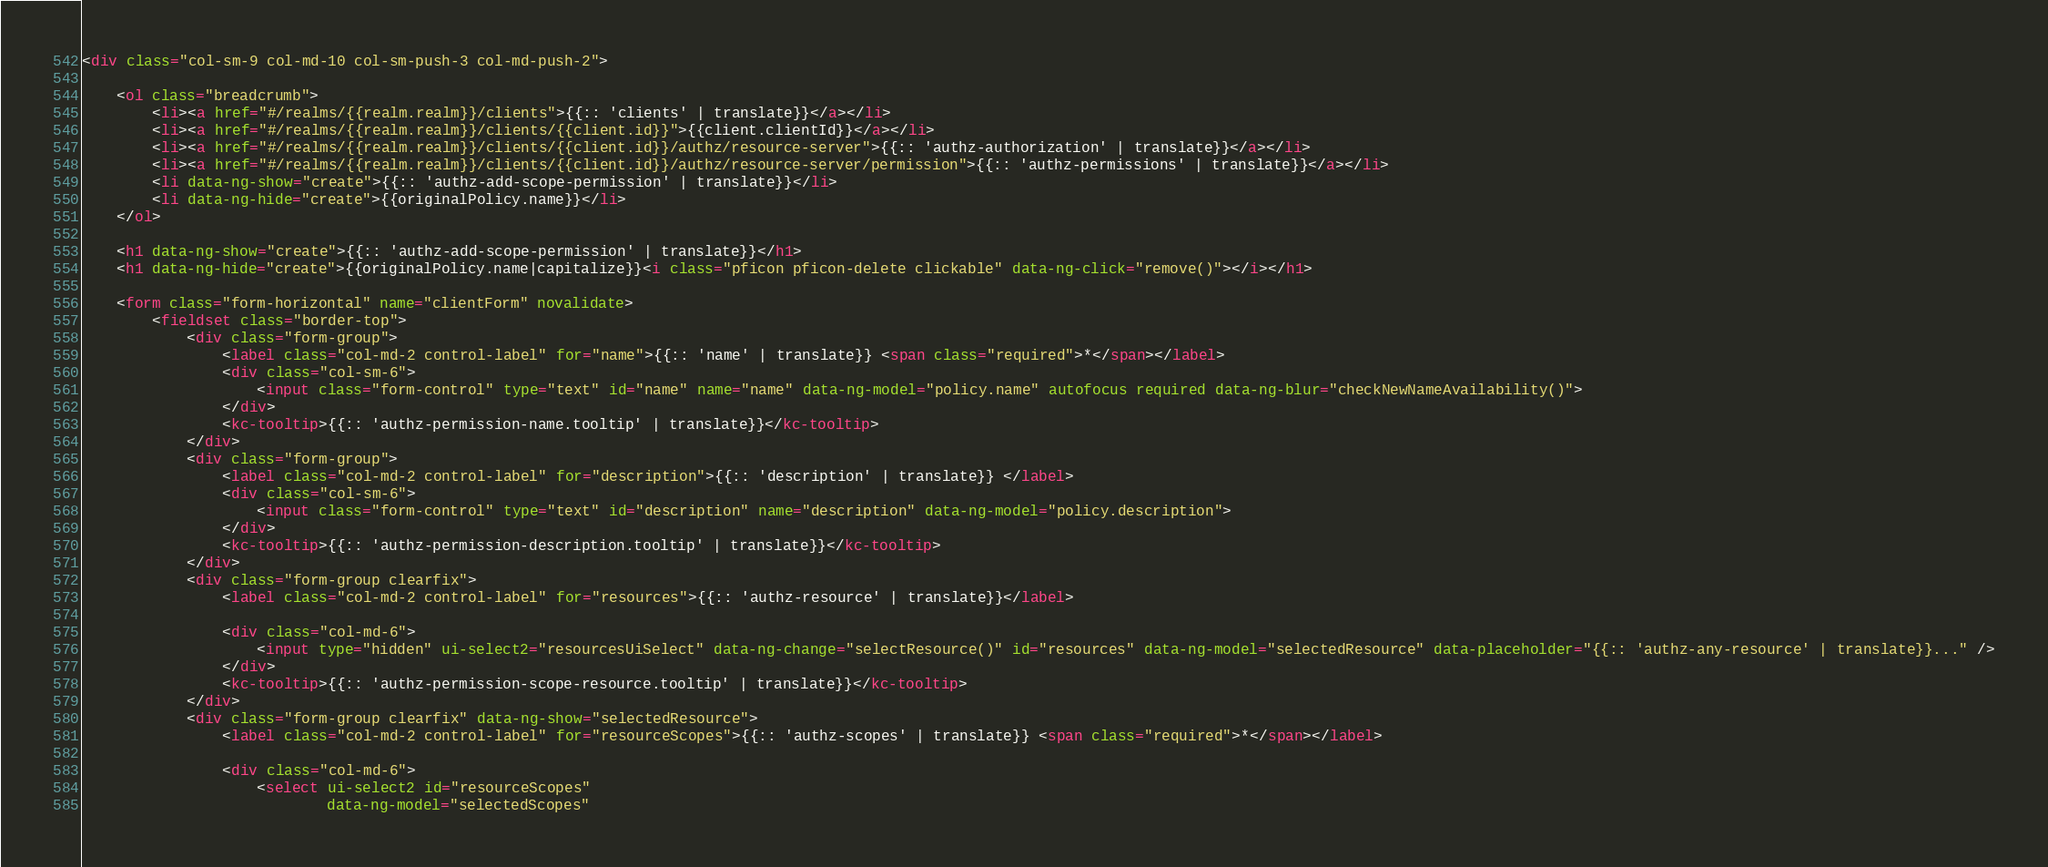<code> <loc_0><loc_0><loc_500><loc_500><_HTML_><div class="col-sm-9 col-md-10 col-sm-push-3 col-md-push-2">

    <ol class="breadcrumb">
        <li><a href="#/realms/{{realm.realm}}/clients">{{:: 'clients' | translate}}</a></li>
        <li><a href="#/realms/{{realm.realm}}/clients/{{client.id}}">{{client.clientId}}</a></li>
        <li><a href="#/realms/{{realm.realm}}/clients/{{client.id}}/authz/resource-server">{{:: 'authz-authorization' | translate}}</a></li>
        <li><a href="#/realms/{{realm.realm}}/clients/{{client.id}}/authz/resource-server/permission">{{:: 'authz-permissions' | translate}}</a></li>
        <li data-ng-show="create">{{:: 'authz-add-scope-permission' | translate}}</li>
        <li data-ng-hide="create">{{originalPolicy.name}}</li>
    </ol>

    <h1 data-ng-show="create">{{:: 'authz-add-scope-permission' | translate}}</h1>
    <h1 data-ng-hide="create">{{originalPolicy.name|capitalize}}<i class="pficon pficon-delete clickable" data-ng-click="remove()"></i></h1>

    <form class="form-horizontal" name="clientForm" novalidate>
        <fieldset class="border-top">
            <div class="form-group">
                <label class="col-md-2 control-label" for="name">{{:: 'name' | translate}} <span class="required">*</span></label>
                <div class="col-sm-6">
                    <input class="form-control" type="text" id="name" name="name" data-ng-model="policy.name" autofocus required data-ng-blur="checkNewNameAvailability()">
                </div>
                <kc-tooltip>{{:: 'authz-permission-name.tooltip' | translate}}</kc-tooltip>
            </div>
            <div class="form-group">
                <label class="col-md-2 control-label" for="description">{{:: 'description' | translate}} </label>
                <div class="col-sm-6">
                    <input class="form-control" type="text" id="description" name="description" data-ng-model="policy.description">
                </div>
                <kc-tooltip>{{:: 'authz-permission-description.tooltip' | translate}}</kc-tooltip>
            </div>
            <div class="form-group clearfix">
                <label class="col-md-2 control-label" for="resources">{{:: 'authz-resource' | translate}}</label>

                <div class="col-md-6">
                    <input type="hidden" ui-select2="resourcesUiSelect" data-ng-change="selectResource()" id="resources" data-ng-model="selectedResource" data-placeholder="{{:: 'authz-any-resource' | translate}}..." />
                </div>
                <kc-tooltip>{{:: 'authz-permission-scope-resource.tooltip' | translate}}</kc-tooltip>
            </div>
            <div class="form-group clearfix" data-ng-show="selectedResource">
                <label class="col-md-2 control-label" for="resourceScopes">{{:: 'authz-scopes' | translate}} <span class="required">*</span></label>

                <div class="col-md-6">
                    <select ui-select2 id="resourceScopes"
                            data-ng-model="selectedScopes"</code> 